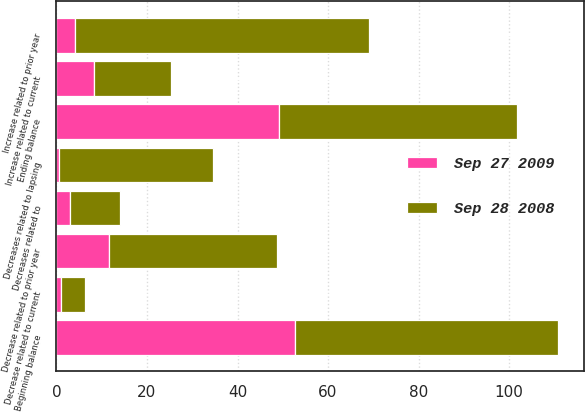Convert chart to OTSL. <chart><loc_0><loc_0><loc_500><loc_500><stacked_bar_chart><ecel><fcel>Beginning balance<fcel>Increase related to prior year<fcel>Decrease related to prior year<fcel>Increase related to current<fcel>Decrease related to current<fcel>Decreases related to<fcel>Decreases related to lapsing<fcel>Ending balance<nl><fcel>Sep 27 2009<fcel>52.6<fcel>4.2<fcel>11.6<fcel>8.4<fcel>0.9<fcel>3<fcel>0.6<fcel>49.1<nl><fcel>Sep 28 2008<fcel>58.3<fcel>64.9<fcel>37.2<fcel>17<fcel>5.4<fcel>11.1<fcel>33.9<fcel>52.6<nl></chart> 